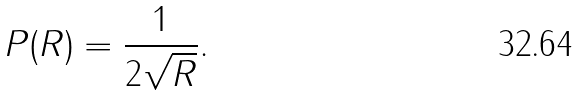<formula> <loc_0><loc_0><loc_500><loc_500>P ( R ) = \frac { 1 } { 2 \sqrt { R } } .</formula> 